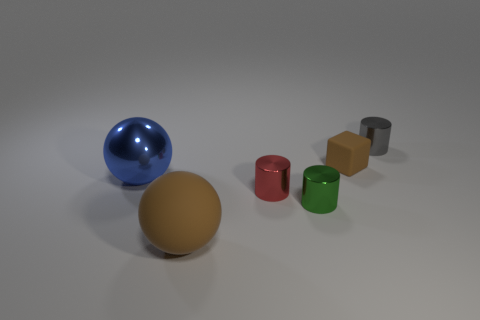Add 2 small cyan cylinders. How many objects exist? 8 Subtract all blocks. How many objects are left? 5 Add 6 big yellow cylinders. How many big yellow cylinders exist? 6 Subtract 0 yellow blocks. How many objects are left? 6 Subtract all small green balls. Subtract all matte spheres. How many objects are left? 5 Add 2 rubber things. How many rubber things are left? 4 